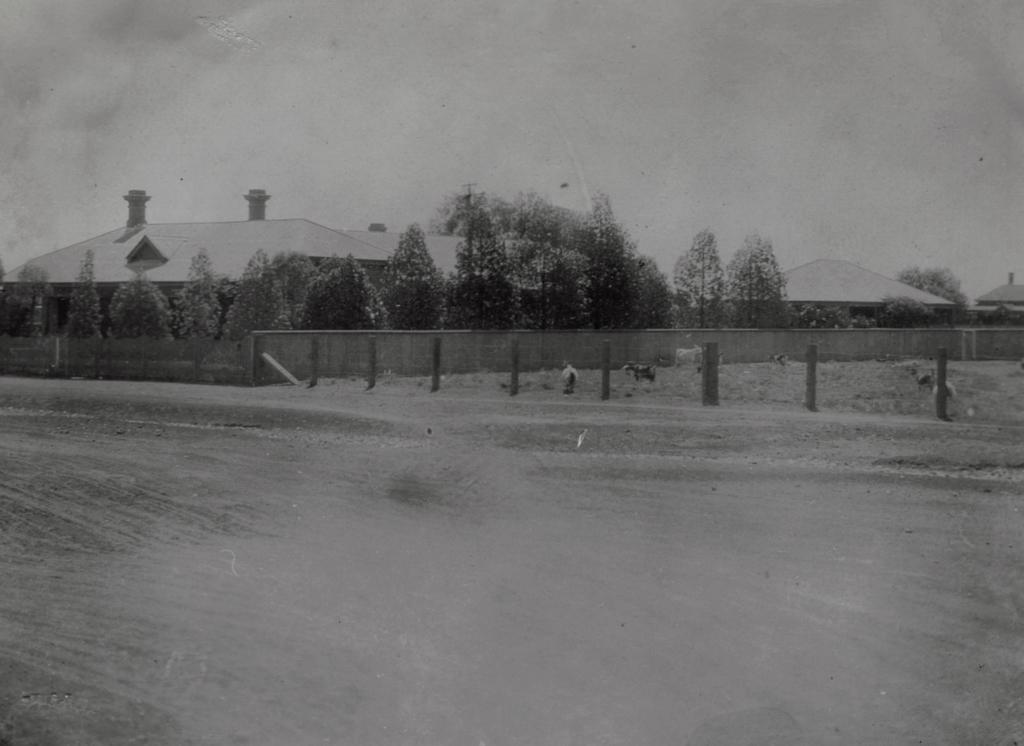What type of structures are present in the image? There are cement poles in the image. What else can be seen near the cement poles? There are animals beside the cement poles. What can be seen in the distance in the image? There are trees and buildings in the background of the image. How many giraffes can be seen interacting with the cement poles in the image? There are no giraffes present in the image; the animals near the cement poles are not giraffes. Are there any giants visible in the image? There are no giants present in the image. 